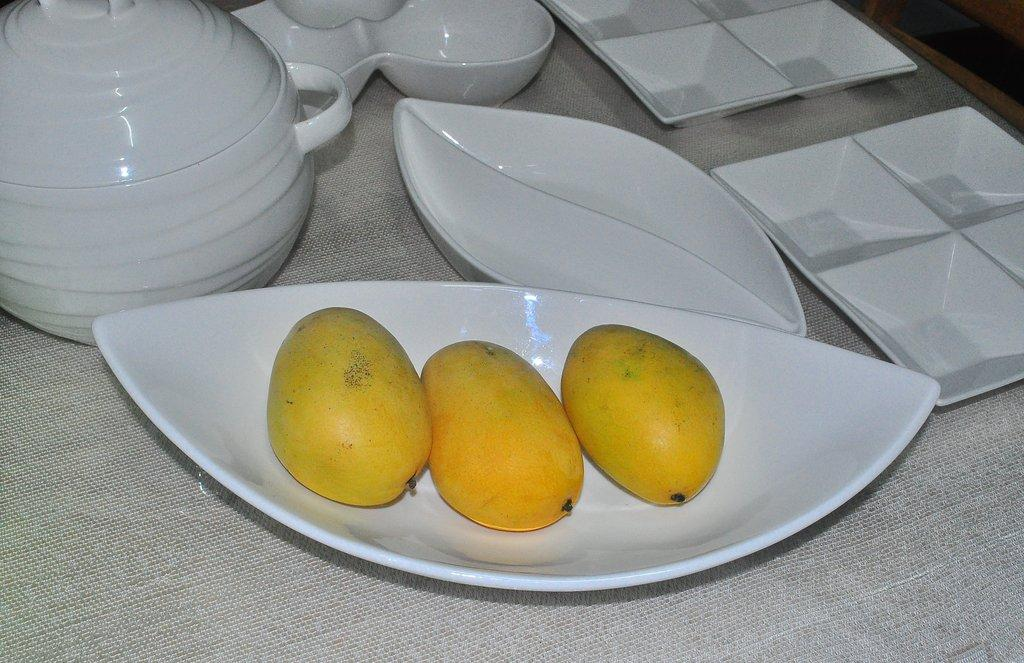What type of fruit is on the plate in the image? There are mangoes on a plate in the image. How many plates are visible in the image? There are plates in the image. Are there any bowls visible in the image? Yes, there are bowls in the image. What is located on the table in the image? There is a kettle on the table in the image. What is covering the table in the image? The table is covered with a silver-colored cloth. Can you see the sun setting over the sea in the image? There is no sea or sun visible in the image; it features a table with various items on it. 